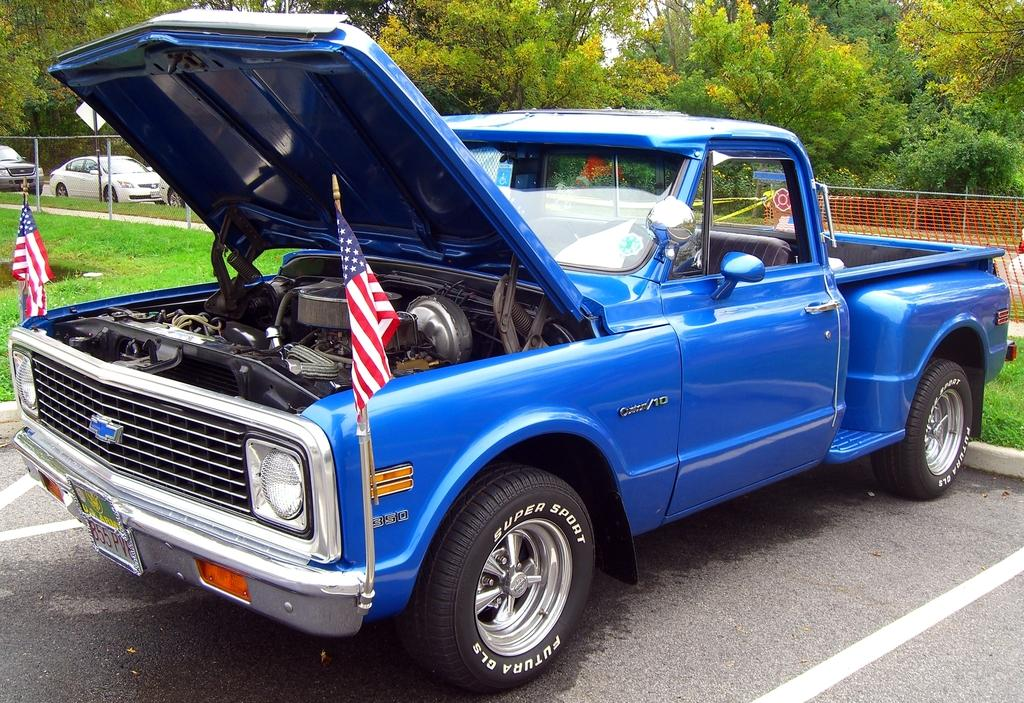What can be seen on the road in the image? There are vehicles on the road in the image. What is unique about one of the vehicles? There are flags on a vehicle in the image. What is present alongside the road in the image? There is a fence in the image. What is used to catch or hold objects in the image? There is a net in the image. What structure is holding a board in the image? There is a pole with a board in the image. What type of natural scenery is visible in the background of the image? There are trees in the background of the image. What language is being spoken by the trees in the background of the image? There is no indication that the trees are speaking any language in the image. What type of frame is holding the vehicles in the image? There is no frame holding the vehicles in the image; they are on the road. 